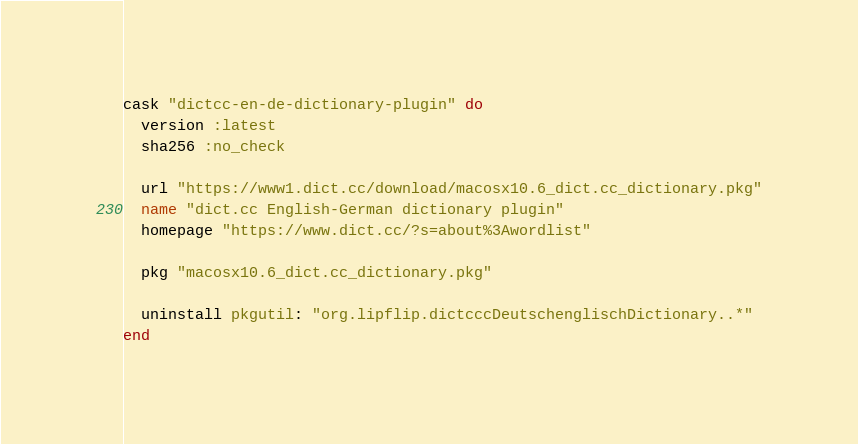Convert code to text. <code><loc_0><loc_0><loc_500><loc_500><_Ruby_>cask "dictcc-en-de-dictionary-plugin" do
  version :latest
  sha256 :no_check

  url "https://www1.dict.cc/download/macosx10.6_dict.cc_dictionary.pkg"
  name "dict.cc English-German dictionary plugin"
  homepage "https://www.dict.cc/?s=about%3Awordlist"

  pkg "macosx10.6_dict.cc_dictionary.pkg"

  uninstall pkgutil: "org.lipflip.dictcccDeutschenglischDictionary..*"
end
</code> 